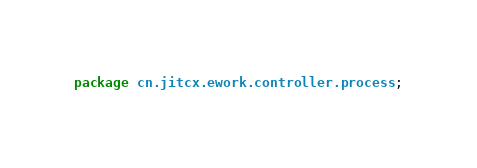Convert code to text. <code><loc_0><loc_0><loc_500><loc_500><_Java_>package cn.jitcx.ework.controller.process;</code> 